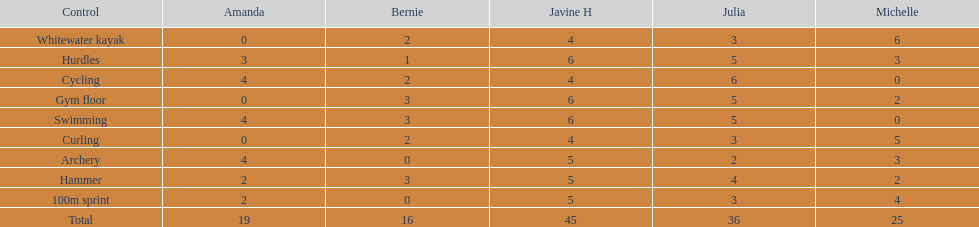Who garnered the most total points? Javine H. 